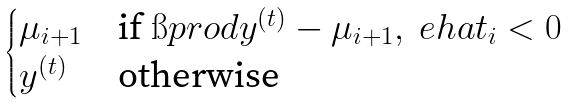Convert formula to latex. <formula><loc_0><loc_0><loc_500><loc_500>\begin{cases} \mu _ { i + 1 } & \text {if } \i p r o d { y ^ { ( t ) } - \mu _ { i + 1 } , \ e h a t _ { i } } < 0 \\ y ^ { ( t ) } & \text {otherwise} \end{cases}</formula> 